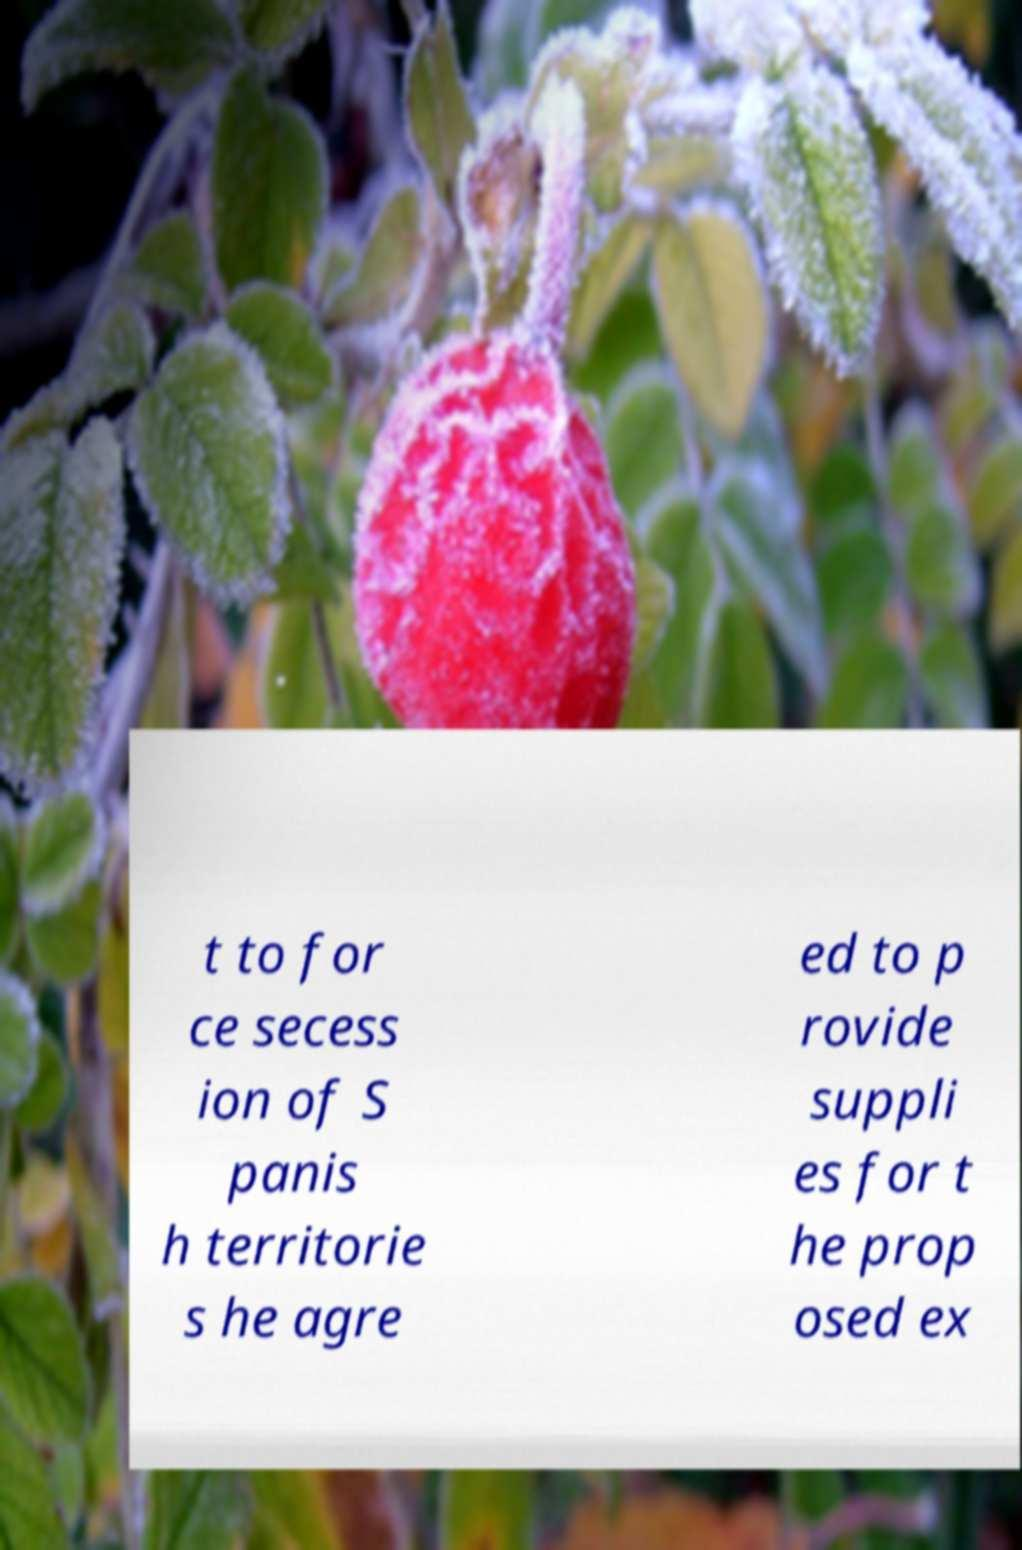Could you extract and type out the text from this image? t to for ce secess ion of S panis h territorie s he agre ed to p rovide suppli es for t he prop osed ex 